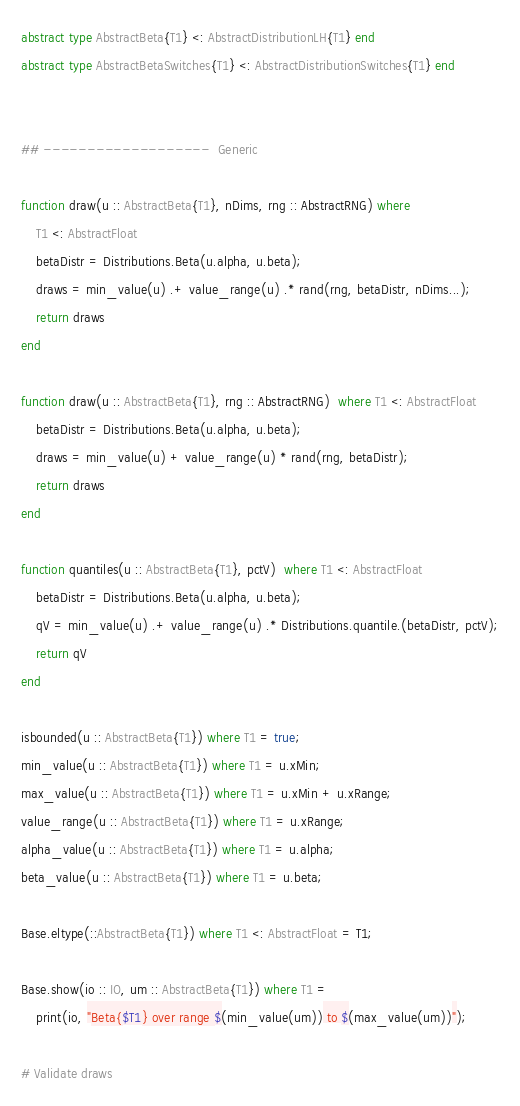<code> <loc_0><loc_0><loc_500><loc_500><_Julia_>abstract type AbstractBeta{T1} <: AbstractDistributionLH{T1} end
abstract type AbstractBetaSwitches{T1} <: AbstractDistributionSwitches{T1} end


## -------------------  Generic

function draw(u :: AbstractBeta{T1}, nDims, rng :: AbstractRNG) where 
    T1 <: AbstractFloat
    betaDistr = Distributions.Beta(u.alpha, u.beta);
    draws = min_value(u) .+ value_range(u) .* rand(rng, betaDistr, nDims...);
    return draws
end

function draw(u :: AbstractBeta{T1}, rng :: AbstractRNG)  where T1 <: AbstractFloat 
    betaDistr = Distributions.Beta(u.alpha, u.beta);
    draws = min_value(u) + value_range(u) * rand(rng, betaDistr);
    return draws
end

function quantiles(u :: AbstractBeta{T1}, pctV)  where T1 <: AbstractFloat
    betaDistr = Distributions.Beta(u.alpha, u.beta);
    qV = min_value(u) .+ value_range(u) .* Distributions.quantile.(betaDistr, pctV);
    return qV
end

isbounded(u :: AbstractBeta{T1}) where T1 = true;
min_value(u :: AbstractBeta{T1}) where T1 = u.xMin;
max_value(u :: AbstractBeta{T1}) where T1 = u.xMin + u.xRange;
value_range(u :: AbstractBeta{T1}) where T1 = u.xRange;
alpha_value(u :: AbstractBeta{T1}) where T1 = u.alpha;
beta_value(u :: AbstractBeta{T1}) where T1 = u.beta;

Base.eltype(::AbstractBeta{T1}) where T1 <: AbstractFloat = T1;

Base.show(io :: IO, um :: AbstractBeta{T1}) where T1 = 
    print(io, "Beta{$T1} over range $(min_value(um)) to $(max_value(um))");

# Validate draws</code> 